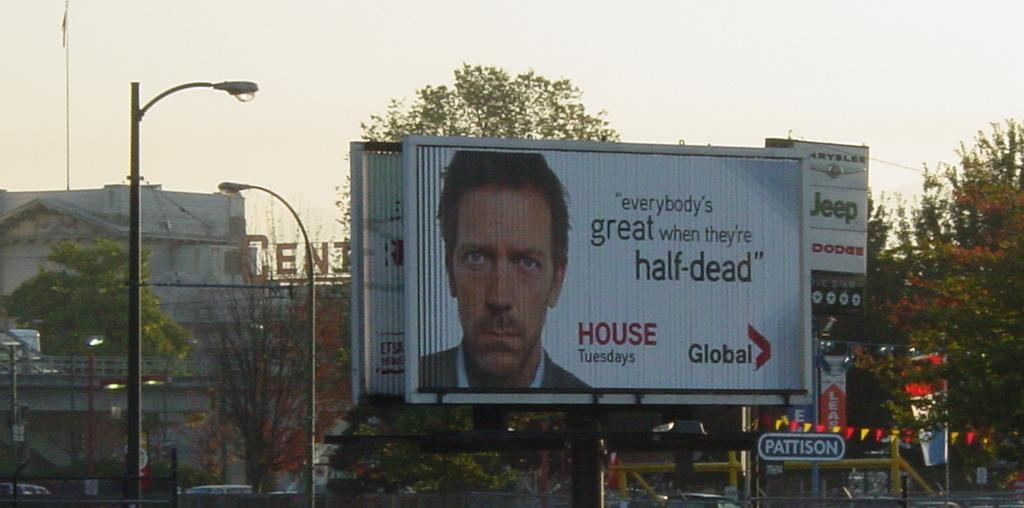<image>
Present a compact description of the photo's key features. a large billboard featuring gregory house and a quote from the show. 